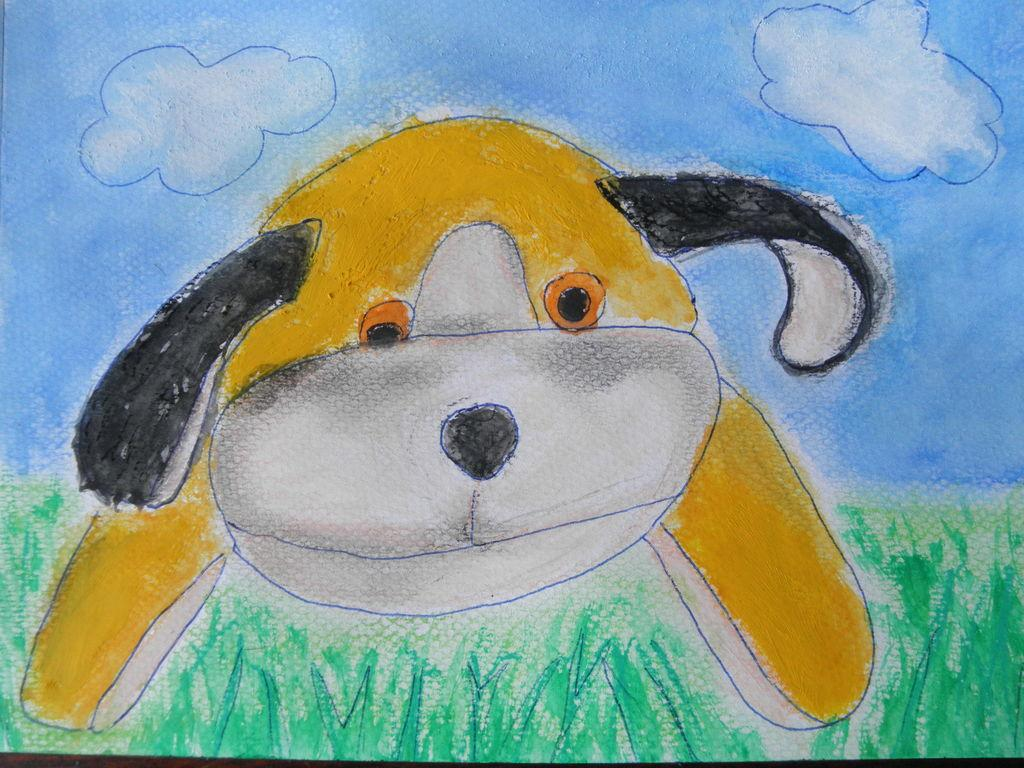What type of toy is in the image? There is a toy dog in the image. What colors can be seen on the toy dog? The toy dog has yellow, black, and white colors. What type of terrain is visible in the image? There is grass visible in the image. What can be seen in the sky in the image? There are clouds in the sky, and the sky is blue. How many children are playing with the toy dog in the image? There are no children present in the image; it only features a toy dog. Can you see a plane flying in the sky in the image? There is no plane visible in the image; only clouds and a blue sky are present. 